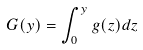Convert formula to latex. <formula><loc_0><loc_0><loc_500><loc_500>G ( y ) = \int _ { 0 } ^ { y } g ( z ) d z</formula> 